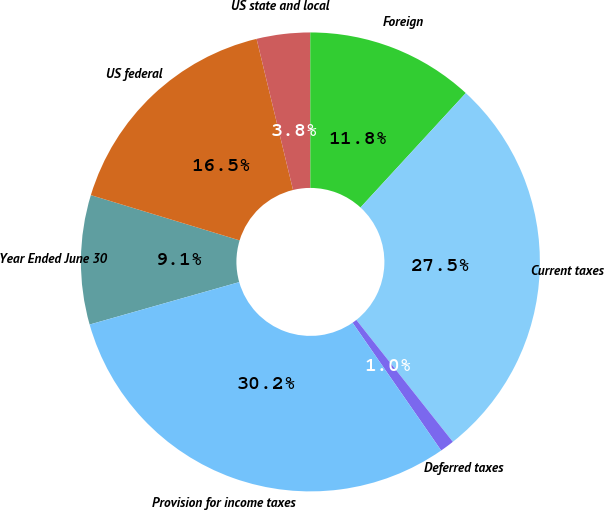Convert chart. <chart><loc_0><loc_0><loc_500><loc_500><pie_chart><fcel>Year Ended June 30<fcel>US federal<fcel>US state and local<fcel>Foreign<fcel>Current taxes<fcel>Deferred taxes<fcel>Provision for income taxes<nl><fcel>9.1%<fcel>16.53%<fcel>3.76%<fcel>11.85%<fcel>27.5%<fcel>1.01%<fcel>30.25%<nl></chart> 